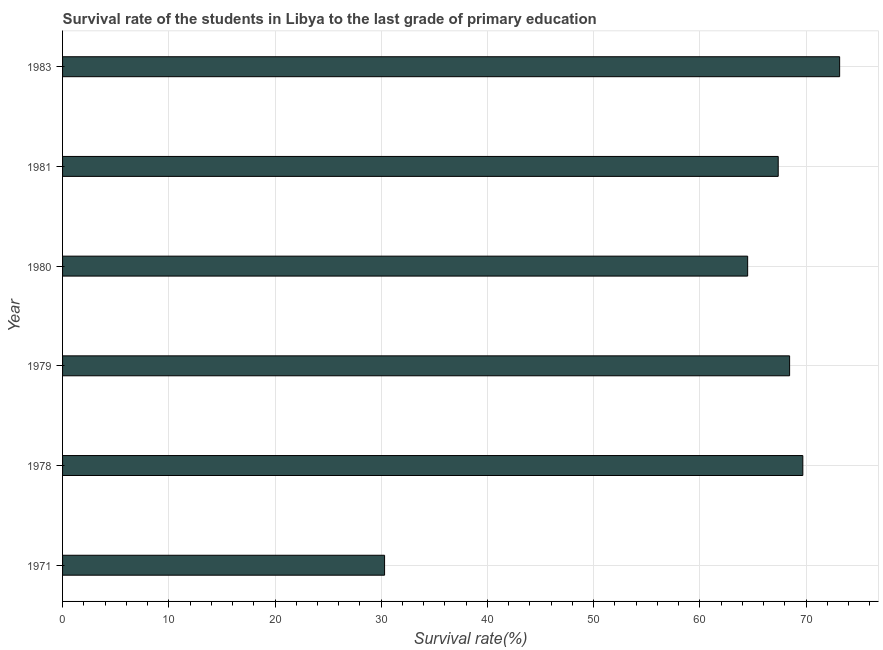Does the graph contain grids?
Keep it short and to the point. Yes. What is the title of the graph?
Make the answer very short. Survival rate of the students in Libya to the last grade of primary education. What is the label or title of the X-axis?
Provide a succinct answer. Survival rate(%). What is the label or title of the Y-axis?
Your answer should be compact. Year. What is the survival rate in primary education in 1971?
Provide a succinct answer. 30.31. Across all years, what is the maximum survival rate in primary education?
Ensure brevity in your answer.  73.16. Across all years, what is the minimum survival rate in primary education?
Give a very brief answer. 30.31. In which year was the survival rate in primary education maximum?
Provide a succinct answer. 1983. In which year was the survival rate in primary education minimum?
Offer a very short reply. 1971. What is the sum of the survival rate in primary education?
Offer a very short reply. 373.47. What is the difference between the survival rate in primary education in 1978 and 1983?
Make the answer very short. -3.47. What is the average survival rate in primary education per year?
Provide a short and direct response. 62.25. What is the median survival rate in primary education?
Provide a succinct answer. 67.91. Do a majority of the years between 1979 and 1978 (inclusive) have survival rate in primary education greater than 46 %?
Offer a very short reply. No. What is the ratio of the survival rate in primary education in 1980 to that in 1983?
Give a very brief answer. 0.88. Is the survival rate in primary education in 1980 less than that in 1981?
Your answer should be very brief. Yes. Is the difference between the survival rate in primary education in 1971 and 1981 greater than the difference between any two years?
Keep it short and to the point. No. What is the difference between the highest and the second highest survival rate in primary education?
Your answer should be compact. 3.47. Is the sum of the survival rate in primary education in 1981 and 1983 greater than the maximum survival rate in primary education across all years?
Ensure brevity in your answer.  Yes. What is the difference between the highest and the lowest survival rate in primary education?
Offer a terse response. 42.84. How many bars are there?
Offer a terse response. 6. Are all the bars in the graph horizontal?
Your answer should be compact. Yes. Are the values on the major ticks of X-axis written in scientific E-notation?
Provide a succinct answer. No. What is the Survival rate(%) in 1971?
Your answer should be very brief. 30.31. What is the Survival rate(%) of 1978?
Keep it short and to the point. 69.69. What is the Survival rate(%) in 1979?
Give a very brief answer. 68.45. What is the Survival rate(%) of 1980?
Ensure brevity in your answer.  64.5. What is the Survival rate(%) of 1981?
Your response must be concise. 67.37. What is the Survival rate(%) of 1983?
Provide a short and direct response. 73.16. What is the difference between the Survival rate(%) in 1971 and 1978?
Your response must be concise. -39.38. What is the difference between the Survival rate(%) in 1971 and 1979?
Offer a terse response. -38.13. What is the difference between the Survival rate(%) in 1971 and 1980?
Make the answer very short. -34.18. What is the difference between the Survival rate(%) in 1971 and 1981?
Your answer should be very brief. -37.06. What is the difference between the Survival rate(%) in 1971 and 1983?
Make the answer very short. -42.84. What is the difference between the Survival rate(%) in 1978 and 1979?
Ensure brevity in your answer.  1.24. What is the difference between the Survival rate(%) in 1978 and 1980?
Your answer should be compact. 5.19. What is the difference between the Survival rate(%) in 1978 and 1981?
Give a very brief answer. 2.32. What is the difference between the Survival rate(%) in 1978 and 1983?
Keep it short and to the point. -3.47. What is the difference between the Survival rate(%) in 1979 and 1980?
Provide a short and direct response. 3.95. What is the difference between the Survival rate(%) in 1979 and 1981?
Your answer should be compact. 1.07. What is the difference between the Survival rate(%) in 1979 and 1983?
Your answer should be very brief. -4.71. What is the difference between the Survival rate(%) in 1980 and 1981?
Provide a short and direct response. -2.88. What is the difference between the Survival rate(%) in 1980 and 1983?
Offer a terse response. -8.66. What is the difference between the Survival rate(%) in 1981 and 1983?
Give a very brief answer. -5.78. What is the ratio of the Survival rate(%) in 1971 to that in 1978?
Provide a succinct answer. 0.43. What is the ratio of the Survival rate(%) in 1971 to that in 1979?
Provide a succinct answer. 0.44. What is the ratio of the Survival rate(%) in 1971 to that in 1980?
Ensure brevity in your answer.  0.47. What is the ratio of the Survival rate(%) in 1971 to that in 1981?
Offer a terse response. 0.45. What is the ratio of the Survival rate(%) in 1971 to that in 1983?
Make the answer very short. 0.41. What is the ratio of the Survival rate(%) in 1978 to that in 1980?
Give a very brief answer. 1.08. What is the ratio of the Survival rate(%) in 1978 to that in 1981?
Your answer should be compact. 1.03. What is the ratio of the Survival rate(%) in 1978 to that in 1983?
Your response must be concise. 0.95. What is the ratio of the Survival rate(%) in 1979 to that in 1980?
Your answer should be compact. 1.06. What is the ratio of the Survival rate(%) in 1979 to that in 1983?
Provide a short and direct response. 0.94. What is the ratio of the Survival rate(%) in 1980 to that in 1983?
Your answer should be compact. 0.88. What is the ratio of the Survival rate(%) in 1981 to that in 1983?
Offer a terse response. 0.92. 